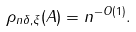<formula> <loc_0><loc_0><loc_500><loc_500>\rho _ { n \delta , \xi } ( A ) = n ^ { - O ( 1 ) } .</formula> 